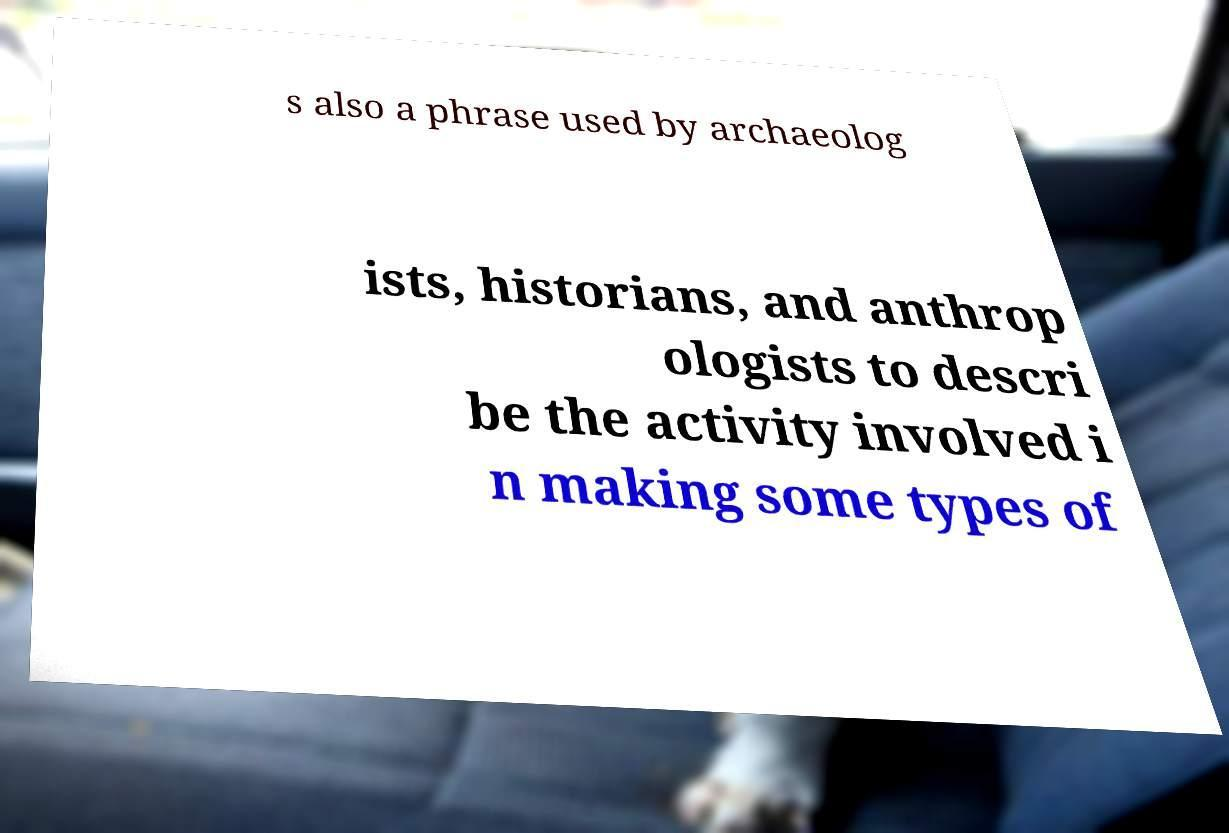I need the written content from this picture converted into text. Can you do that? s also a phrase used by archaeolog ists, historians, and anthrop ologists to descri be the activity involved i n making some types of 